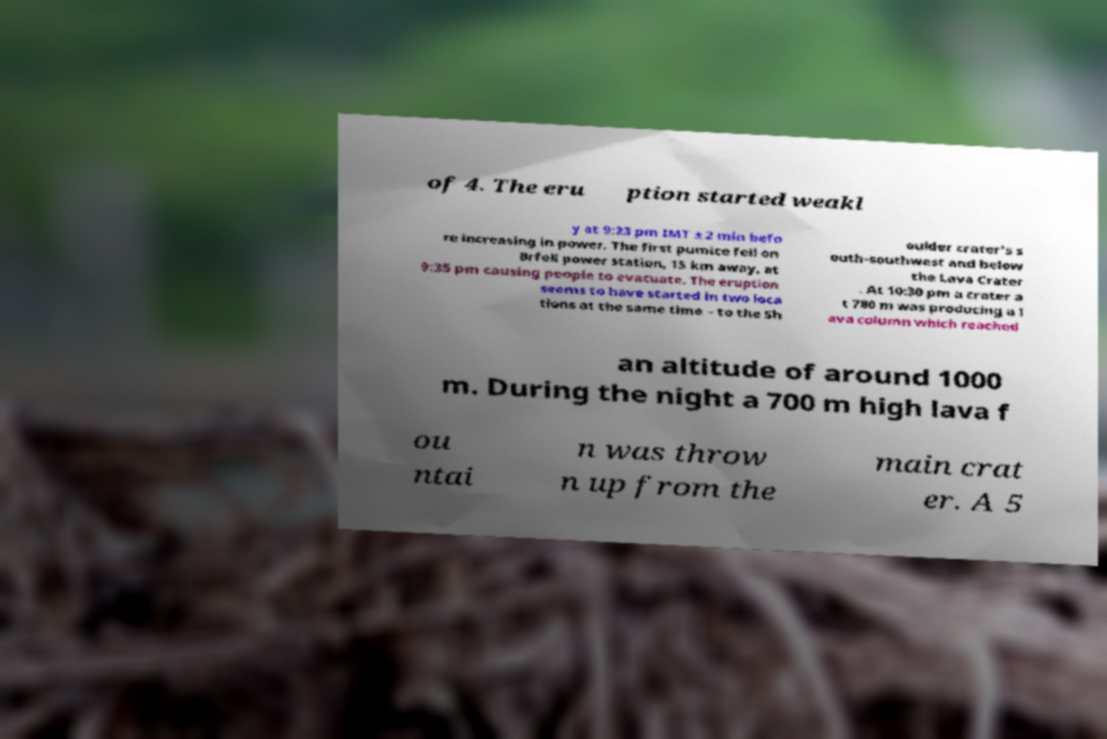Can you accurately transcribe the text from the provided image for me? of 4. The eru ption started weakl y at 9:23 pm IMT ± 2 min befo re increasing in power. The first pumice fell on Brfell power station, 15 km away, at 9:35 pm causing people to evacuate. The eruption seems to have started in two loca tions at the same time – to the Sh oulder crater's s outh-southwest and below the Lava Crater . At 10:30 pm a crater a t 780 m was producing a l ava column which reached an altitude of around 1000 m. During the night a 700 m high lava f ou ntai n was throw n up from the main crat er. A 5 